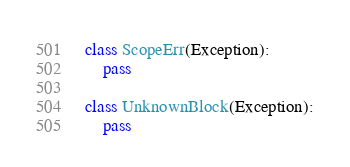Convert code to text. <code><loc_0><loc_0><loc_500><loc_500><_Python_>
class ScopeErr(Exception):
    pass

class UnknownBlock(Exception):
	pass</code> 